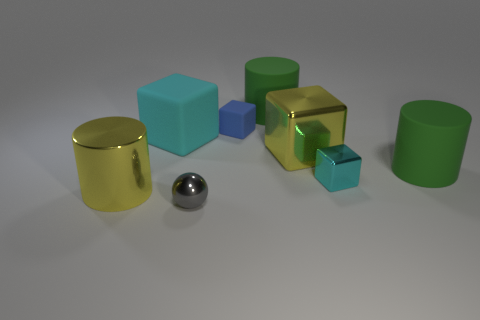Which objects in the image could potentially roll if pushed? The spherical metal object and the cylindrical green and gold objects have rounded shapes that could allow them to roll if they were pushed. 